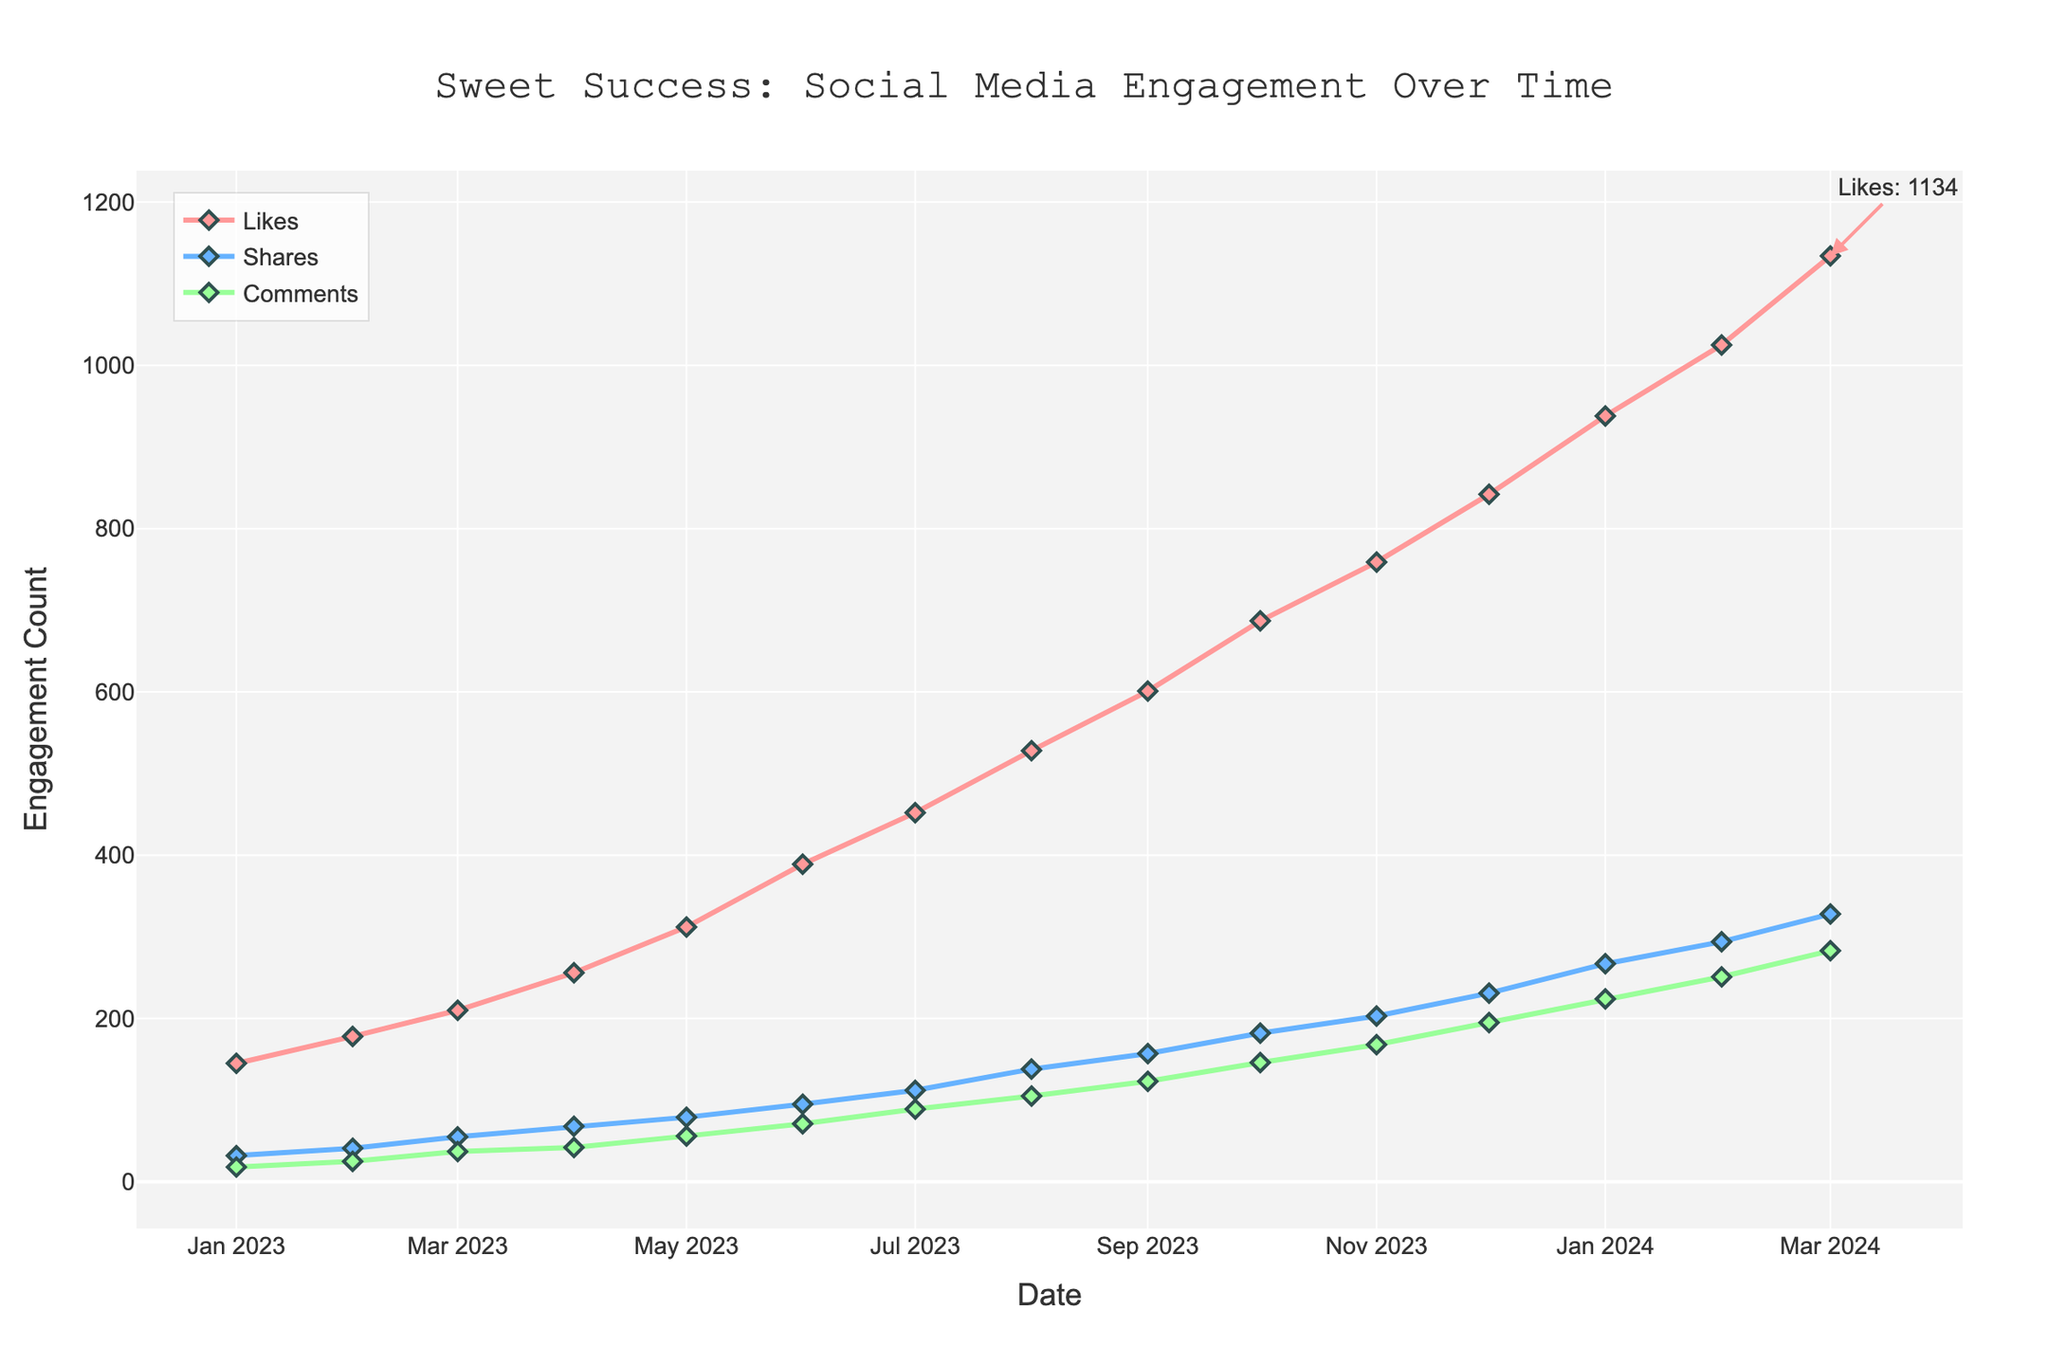What is the total number of likes received by the bakery in March 2024? On the plot, find the value corresponding to the likes for March 2024 by identifying the x-axis label "March 2024" and then trace upward to the likes line. The y-value marked at this point indicates the number of likes.
Answer: 1134 How much did the number of comments increase from June 2023 to December 2023? Identify the comments count for both June 2023 and December 2023 by looking at the corresponding points on the comments trend line on the plot. Subtract the number of comments in June 2023 from the number in December 2023 to find the increase.
Answer: 195 - 71 = 124 Which month saw the highest number of shares in 2023? Examine the shares line on the plot for the year 2023 to find the peak point. The month at which this peak value occurs is the month with the highest shares.
Answer: December 2023 What is the average number of likes from January 2023 to December 2023? Sum the likes from January 2023 to December 2023 and divide by the number of months (12). Refer to the data points on the likes line for each month within this period.
Answer: (145 + 178 + 210 + 256 + 312 + 389 + 452 + 528 + 601 + 687 + 759 + 842) / 12 = 4565 / 12 ≈ 380.42 How does the number of shares in February 2024 compare to December 2023? Check the shares count for both February 2024 and December 2023 by tracing from each month on the x-axis to the shares line. Determine if the February 2024 count is greater than, less than, or equal to that of December 2023.
Answer: 294 (February 2024) is greater than 231 (December 2023) How would you describe the trend of likes from January 2023 to March 2024? Observe the trajectory of the likes line from January 2023 to March 2024 on the plot. Note if the trend is increasing, decreasing, or steady across this time span.
Answer: Increasing What is the difference in the number of shares between January 2023 and January 2024? Identify the points for shares in January 2023 and January 2024 on the plot. Subtract the number of shares in January 2023 from that in January 2024 to find the difference.
Answer: 267 - 32 = 235 Which engagement metric shows the highest count in March 2024? For March 2024, compare the values of likes, shares, and comments by looking at the endpoint values of each trend line. Identify which metric has the highest count.
Answer: Likes: 1134 (highest) 